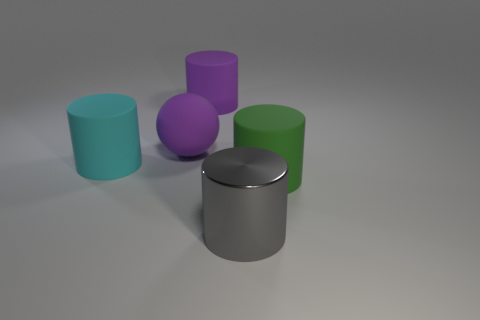Are there any other things that are the same material as the big sphere?
Make the answer very short. Yes. There is a object that is in front of the green rubber thing; does it have the same size as the big rubber sphere?
Give a very brief answer. Yes. What number of other metal objects have the same size as the gray shiny thing?
Provide a short and direct response. 0. What is the size of the cylinder that is the same color as the big ball?
Make the answer very short. Large. Is the large shiny object the same color as the large rubber sphere?
Your answer should be compact. No. What is the shape of the large gray shiny thing?
Offer a terse response. Cylinder. Is there a big rubber cylinder of the same color as the big sphere?
Offer a terse response. Yes. Are there more big green cylinders that are in front of the big gray object than cyan matte cylinders?
Make the answer very short. No. Is the shape of the large cyan matte object the same as the rubber object in front of the big cyan cylinder?
Offer a very short reply. Yes. Are any cyan metallic things visible?
Ensure brevity in your answer.  No. 